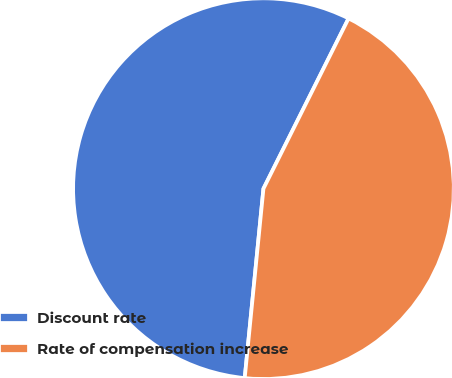<chart> <loc_0><loc_0><loc_500><loc_500><pie_chart><fcel>Discount rate<fcel>Rate of compensation increase<nl><fcel>55.81%<fcel>44.19%<nl></chart> 